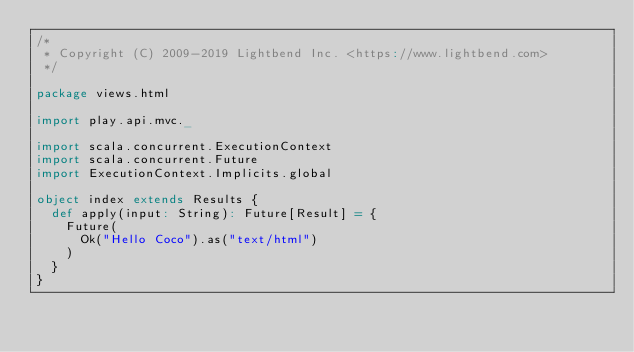<code> <loc_0><loc_0><loc_500><loc_500><_Scala_>/*
 * Copyright (C) 2009-2019 Lightbend Inc. <https://www.lightbend.com>
 */

package views.html

import play.api.mvc._

import scala.concurrent.ExecutionContext
import scala.concurrent.Future
import ExecutionContext.Implicits.global

object index extends Results {
  def apply(input: String): Future[Result] = {
    Future(
      Ok("Hello Coco").as("text/html")
    )
  }
}
</code> 